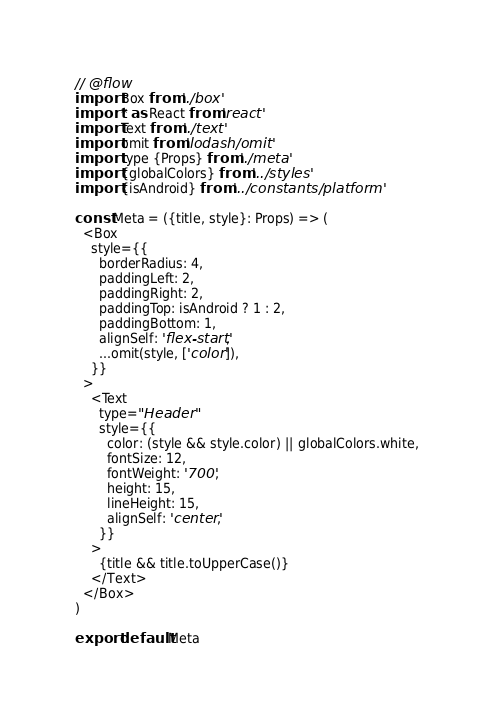Convert code to text. <code><loc_0><loc_0><loc_500><loc_500><_JavaScript_>// @flow
import Box from './box'
import * as React from 'react'
import Text from './text'
import omit from 'lodash/omit'
import type {Props} from './meta'
import {globalColors} from '../styles'
import {isAndroid} from '../constants/platform'

const Meta = ({title, style}: Props) => (
  <Box
    style={{
      borderRadius: 4,
      paddingLeft: 2,
      paddingRight: 2,
      paddingTop: isAndroid ? 1 : 2,
      paddingBottom: 1,
      alignSelf: 'flex-start',
      ...omit(style, ['color']),
    }}
  >
    <Text
      type="Header"
      style={{
        color: (style && style.color) || globalColors.white,
        fontSize: 12,
        fontWeight: '700',
        height: 15,
        lineHeight: 15,
        alignSelf: 'center',
      }}
    >
      {title && title.toUpperCase()}
    </Text>
  </Box>
)

export default Meta
</code> 